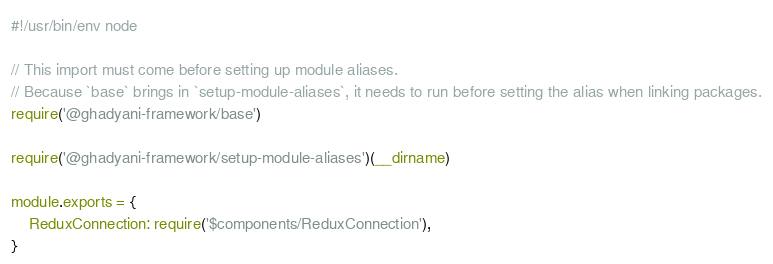Convert code to text. <code><loc_0><loc_0><loc_500><loc_500><_JavaScript_>#!/usr/bin/env node

// This import must come before setting up module aliases.
// Because `base` brings in `setup-module-aliases`, it needs to run before setting the alias when linking packages.
require('@ghadyani-framework/base')

require('@ghadyani-framework/setup-module-aliases')(__dirname)

module.exports = {
	ReduxConnection: require('$components/ReduxConnection'),
}
</code> 